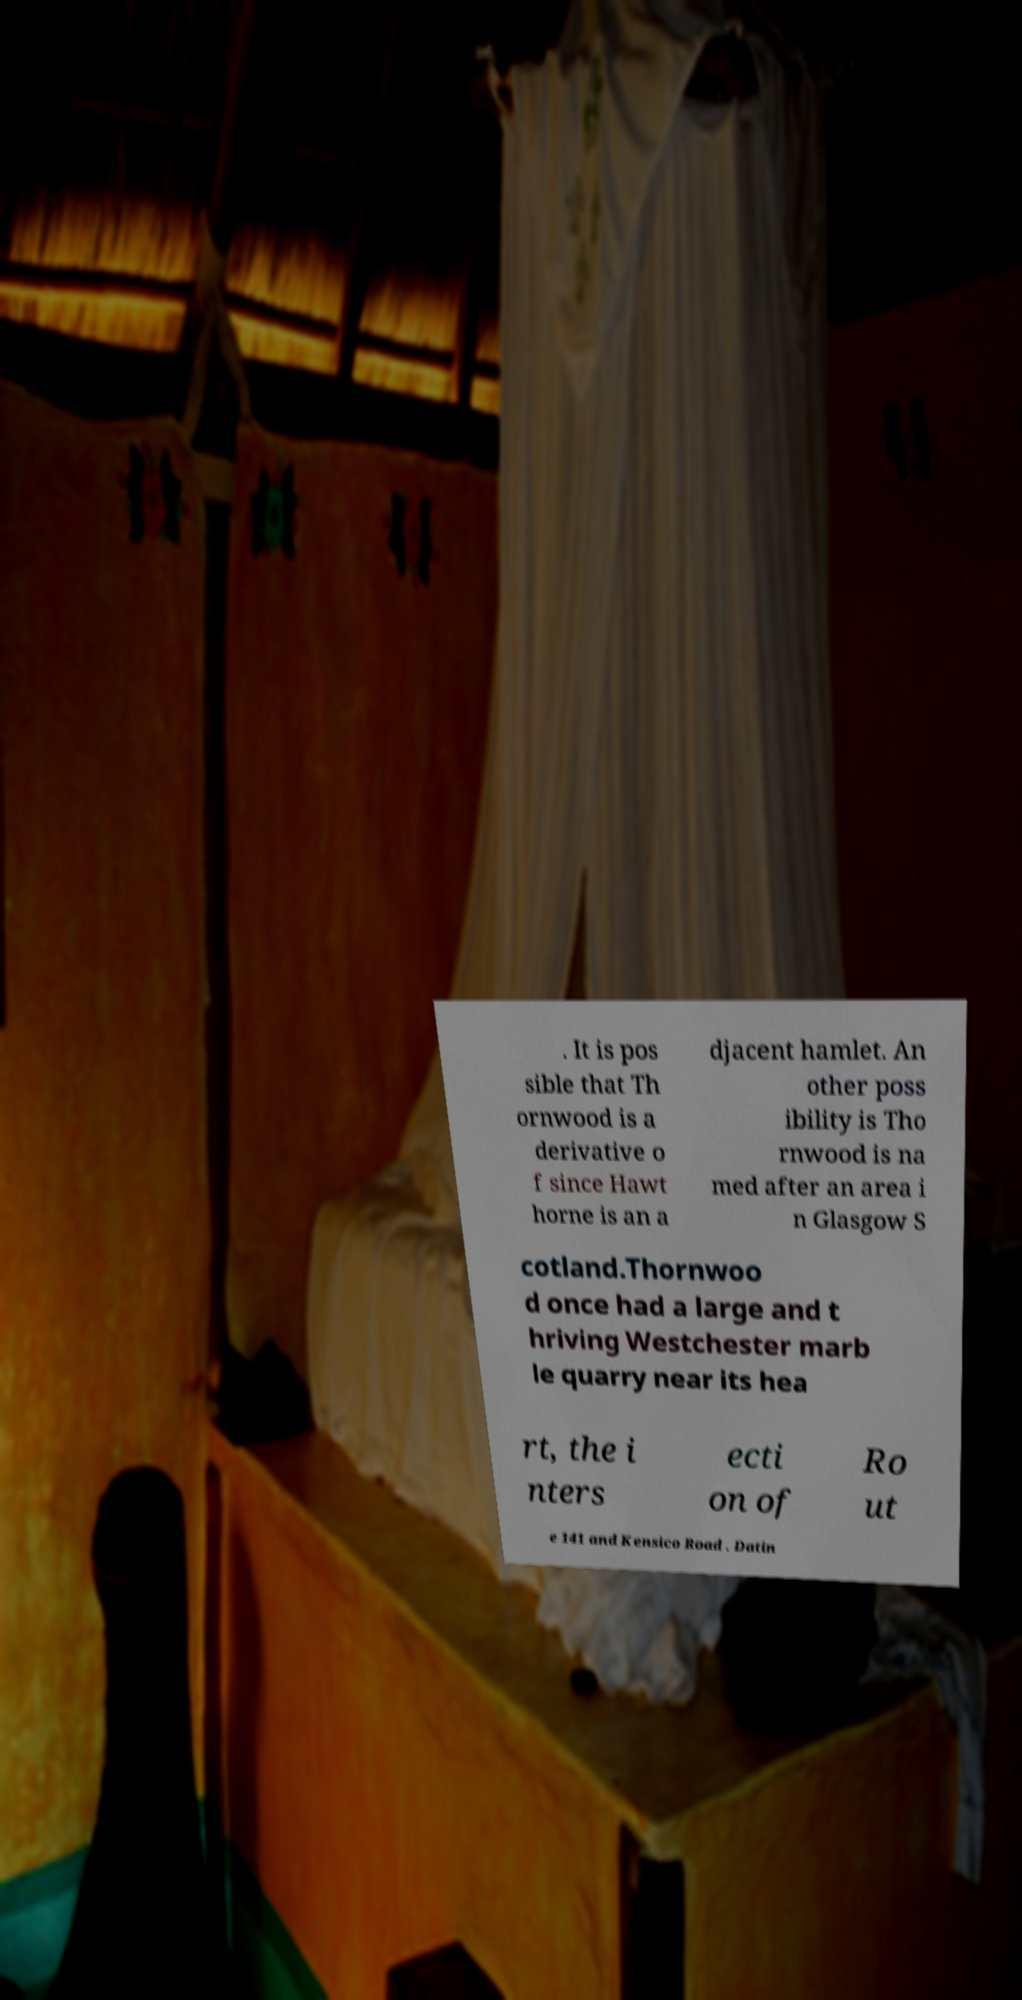For documentation purposes, I need the text within this image transcribed. Could you provide that? . It is pos sible that Th ornwood is a derivative o f since Hawt horne is an a djacent hamlet. An other poss ibility is Tho rnwood is na med after an area i n Glasgow S cotland.Thornwoo d once had a large and t hriving Westchester marb le quarry near its hea rt, the i nters ecti on of Ro ut e 141 and Kensico Road . Datin 